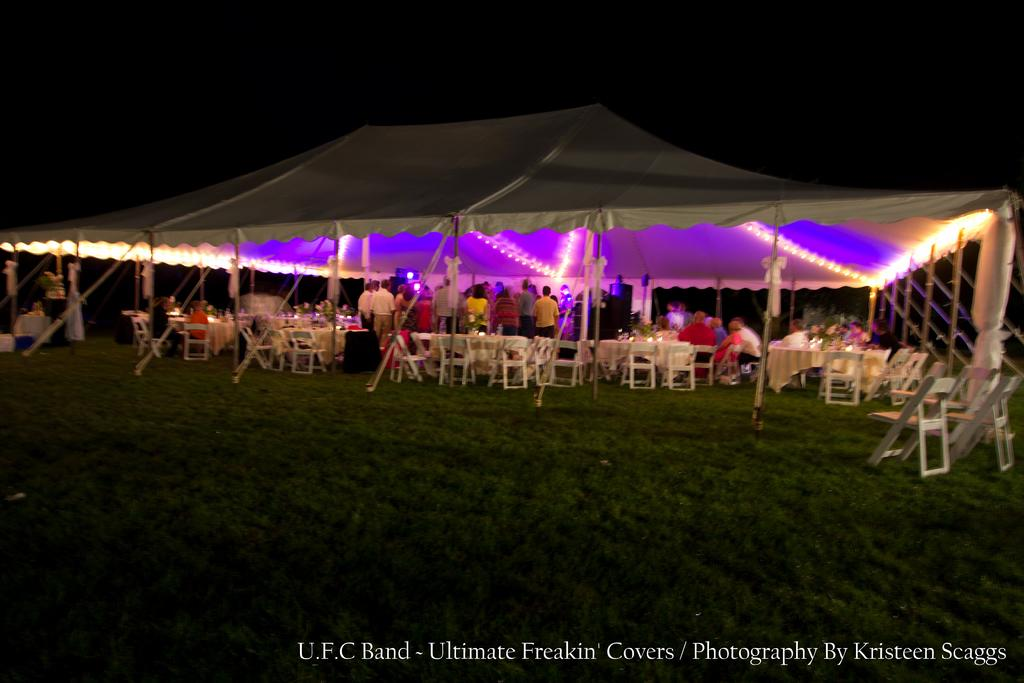What type of structure is present in the image? There is a white color tent in the image. What feature does the tent have? The tent has lights. What type of furniture is visible in the image? There are chairs and tables in the image. What can be seen in terms of human presence in the image? There are people standing in the image. What type of ground surface is visible at the bottom of the image? There is grass at the bottom of the image. What text is present at the bottom of the image? There is some text at the bottom of the image. What type of farm animals can be seen grazing in the image? There are no farm animals present in the image; it features a tent with chairs, tables, and people. What scent is emanating from the image? The image does not have a scent; it is a visual representation. 